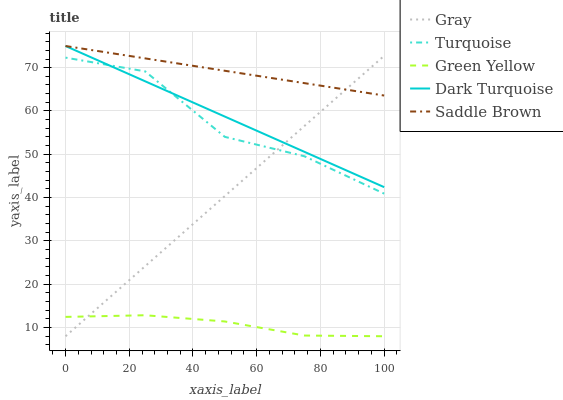Does Green Yellow have the minimum area under the curve?
Answer yes or no. Yes. Does Saddle Brown have the maximum area under the curve?
Answer yes or no. Yes. Does Turquoise have the minimum area under the curve?
Answer yes or no. No. Does Turquoise have the maximum area under the curve?
Answer yes or no. No. Is Dark Turquoise the smoothest?
Answer yes or no. Yes. Is Turquoise the roughest?
Answer yes or no. Yes. Is Green Yellow the smoothest?
Answer yes or no. No. Is Green Yellow the roughest?
Answer yes or no. No. Does Gray have the lowest value?
Answer yes or no. Yes. Does Turquoise have the lowest value?
Answer yes or no. No. Does Dark Turquoise have the highest value?
Answer yes or no. Yes. Does Turquoise have the highest value?
Answer yes or no. No. Is Green Yellow less than Turquoise?
Answer yes or no. Yes. Is Saddle Brown greater than Turquoise?
Answer yes or no. Yes. Does Dark Turquoise intersect Turquoise?
Answer yes or no. Yes. Is Dark Turquoise less than Turquoise?
Answer yes or no. No. Is Dark Turquoise greater than Turquoise?
Answer yes or no. No. Does Green Yellow intersect Turquoise?
Answer yes or no. No. 